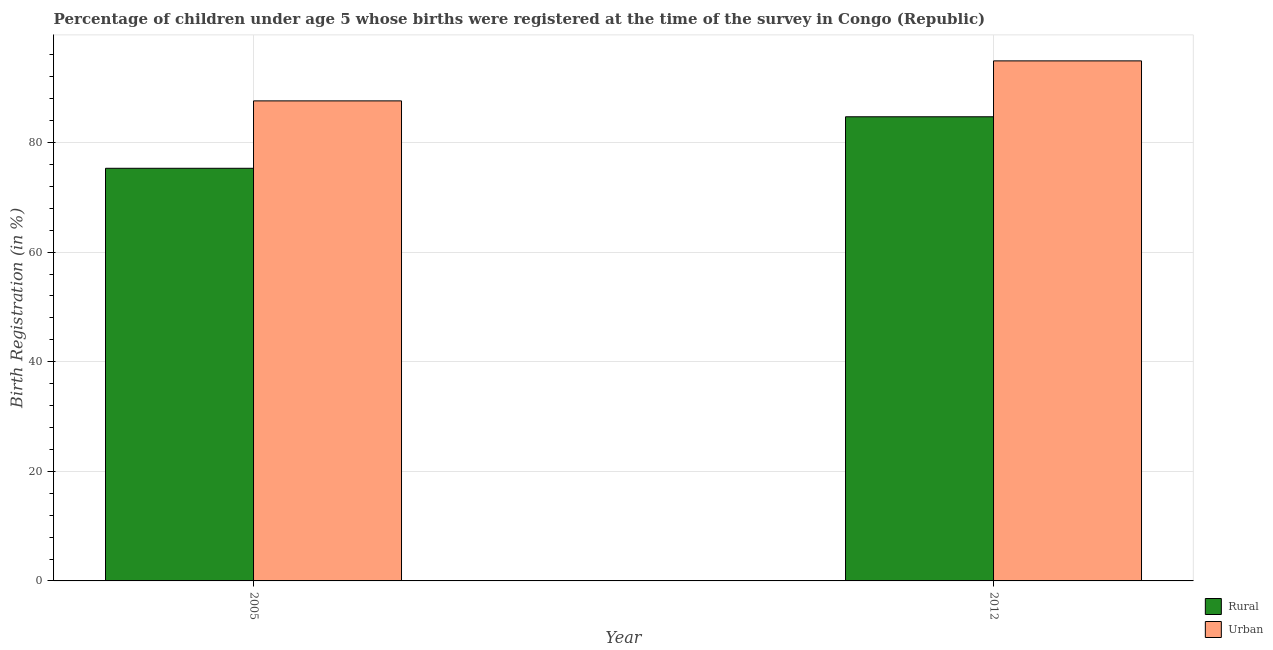What is the urban birth registration in 2012?
Provide a succinct answer. 94.9. Across all years, what is the maximum rural birth registration?
Your response must be concise. 84.7. Across all years, what is the minimum rural birth registration?
Your response must be concise. 75.3. In which year was the rural birth registration maximum?
Your answer should be compact. 2012. What is the total urban birth registration in the graph?
Provide a succinct answer. 182.5. What is the difference between the rural birth registration in 2005 and that in 2012?
Offer a very short reply. -9.4. What is the difference between the rural birth registration in 2005 and the urban birth registration in 2012?
Your answer should be compact. -9.4. What is the average urban birth registration per year?
Offer a very short reply. 91.25. In the year 2012, what is the difference between the rural birth registration and urban birth registration?
Offer a terse response. 0. In how many years, is the urban birth registration greater than 16 %?
Give a very brief answer. 2. What is the ratio of the rural birth registration in 2005 to that in 2012?
Offer a very short reply. 0.89. Is the rural birth registration in 2005 less than that in 2012?
Make the answer very short. Yes. What does the 1st bar from the left in 2005 represents?
Make the answer very short. Rural. What does the 1st bar from the right in 2005 represents?
Keep it short and to the point. Urban. How many bars are there?
Offer a terse response. 4. Are all the bars in the graph horizontal?
Your response must be concise. No. What is the difference between two consecutive major ticks on the Y-axis?
Your answer should be very brief. 20. Are the values on the major ticks of Y-axis written in scientific E-notation?
Provide a short and direct response. No. Does the graph contain grids?
Provide a succinct answer. Yes. How many legend labels are there?
Your answer should be very brief. 2. What is the title of the graph?
Your response must be concise. Percentage of children under age 5 whose births were registered at the time of the survey in Congo (Republic). Does "Travel Items" appear as one of the legend labels in the graph?
Give a very brief answer. No. What is the label or title of the Y-axis?
Provide a short and direct response. Birth Registration (in %). What is the Birth Registration (in %) in Rural in 2005?
Offer a very short reply. 75.3. What is the Birth Registration (in %) of Urban in 2005?
Provide a short and direct response. 87.6. What is the Birth Registration (in %) of Rural in 2012?
Your answer should be very brief. 84.7. What is the Birth Registration (in %) in Urban in 2012?
Your answer should be compact. 94.9. Across all years, what is the maximum Birth Registration (in %) in Rural?
Your answer should be very brief. 84.7. Across all years, what is the maximum Birth Registration (in %) of Urban?
Your answer should be compact. 94.9. Across all years, what is the minimum Birth Registration (in %) of Rural?
Your answer should be compact. 75.3. Across all years, what is the minimum Birth Registration (in %) in Urban?
Your response must be concise. 87.6. What is the total Birth Registration (in %) in Rural in the graph?
Provide a short and direct response. 160. What is the total Birth Registration (in %) of Urban in the graph?
Ensure brevity in your answer.  182.5. What is the difference between the Birth Registration (in %) of Rural in 2005 and that in 2012?
Your answer should be compact. -9.4. What is the difference between the Birth Registration (in %) of Rural in 2005 and the Birth Registration (in %) of Urban in 2012?
Keep it short and to the point. -19.6. What is the average Birth Registration (in %) of Urban per year?
Provide a short and direct response. 91.25. In the year 2012, what is the difference between the Birth Registration (in %) of Rural and Birth Registration (in %) of Urban?
Your answer should be compact. -10.2. What is the ratio of the Birth Registration (in %) of Rural in 2005 to that in 2012?
Offer a terse response. 0.89. What is the ratio of the Birth Registration (in %) in Urban in 2005 to that in 2012?
Ensure brevity in your answer.  0.92. What is the difference between the highest and the second highest Birth Registration (in %) in Rural?
Offer a very short reply. 9.4. What is the difference between the highest and the second highest Birth Registration (in %) in Urban?
Your response must be concise. 7.3. 